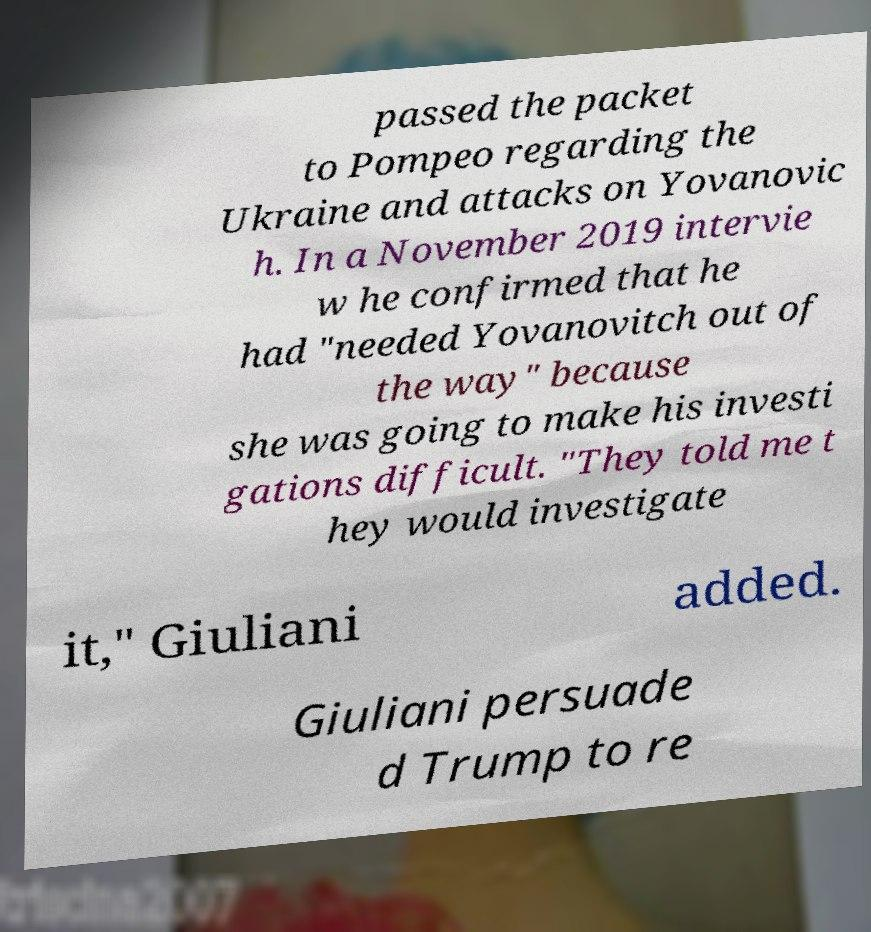For documentation purposes, I need the text within this image transcribed. Could you provide that? passed the packet to Pompeo regarding the Ukraine and attacks on Yovanovic h. In a November 2019 intervie w he confirmed that he had "needed Yovanovitch out of the way" because she was going to make his investi gations difficult. "They told me t hey would investigate it," Giuliani added. Giuliani persuade d Trump to re 